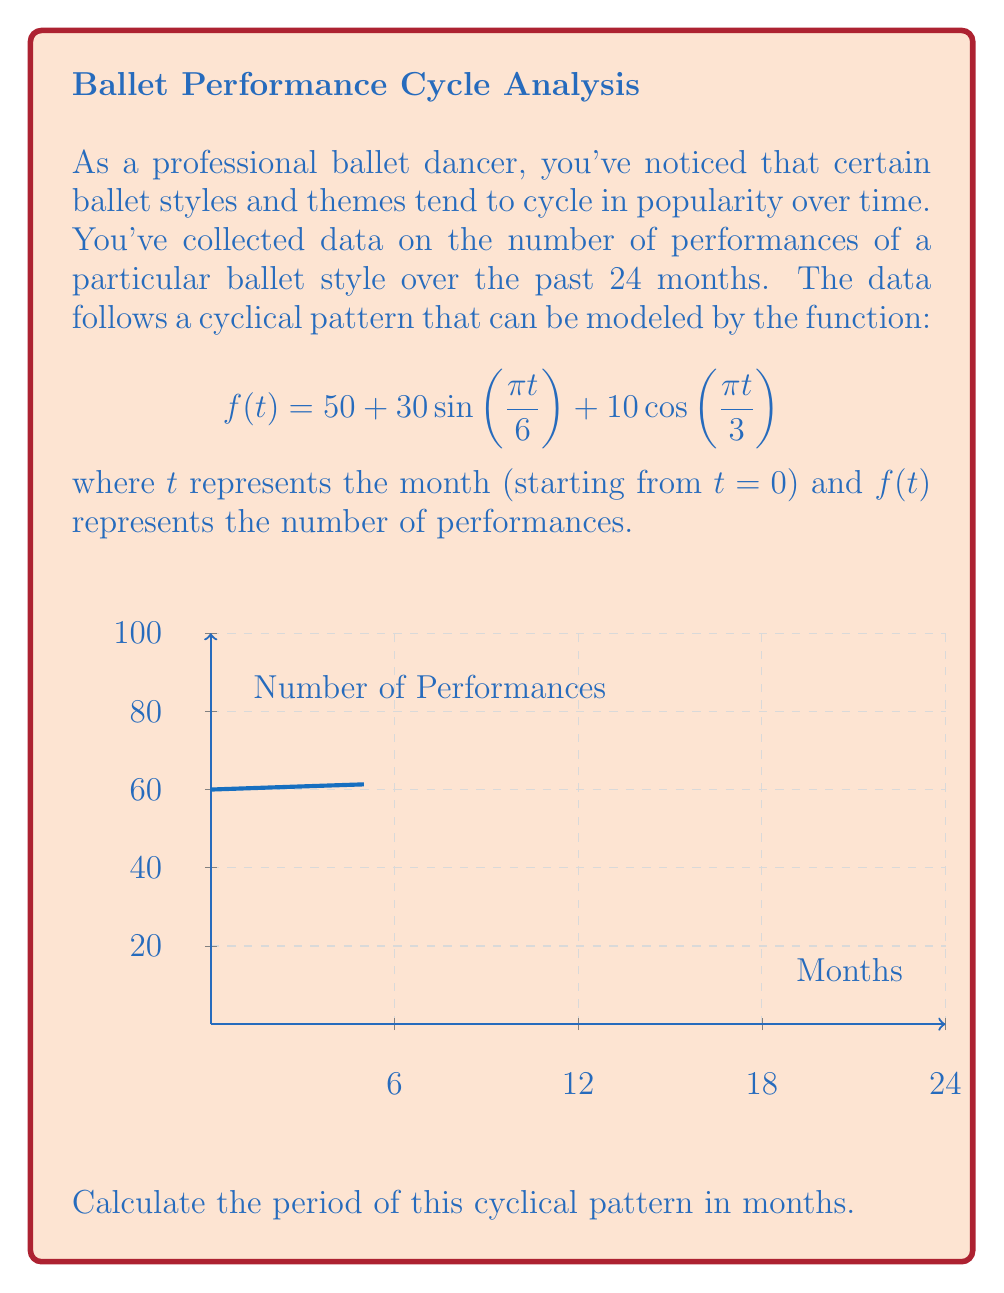Can you answer this question? To find the period of this cyclical pattern, we need to analyze the sinusoidal components of the function:

1) The function is composed of two periodic terms:
   $$30\sin(\frac{\pi t}{6})$$ and $$10\cos(\frac{\pi t}{3})$$

2) For a general sine or cosine function $\sin(at)$ or $\cos(at)$, the period is given by $\frac{2\pi}{|a|}$.

3) For the first term, $30\sin(\frac{\pi t}{6})$:
   Period = $\frac{2\pi}{|\frac{\pi}{6}|} = 12$ months

4) For the second term, $10\cos(\frac{\pi t}{3})$:
   Period = $\frac{2\pi}{|\frac{\pi}{3}|} = 6$ months

5) The overall period of the function will be the least common multiple (LCM) of these individual periods.

6) LCM(12, 6) = 12 months

Therefore, the cyclical pattern repeats every 12 months.
Answer: 12 months 